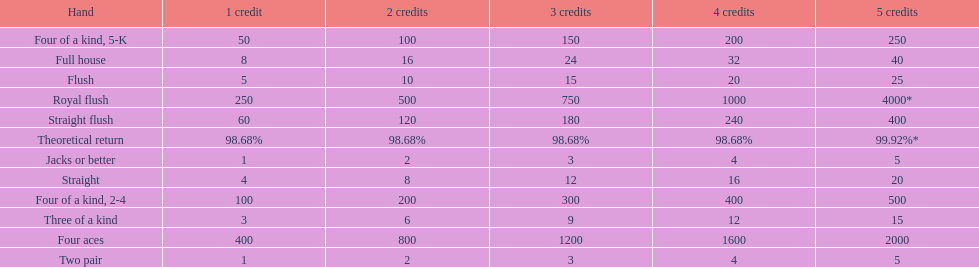Is a 2 credit full house the same as a 5 credit three of a kind? No. 